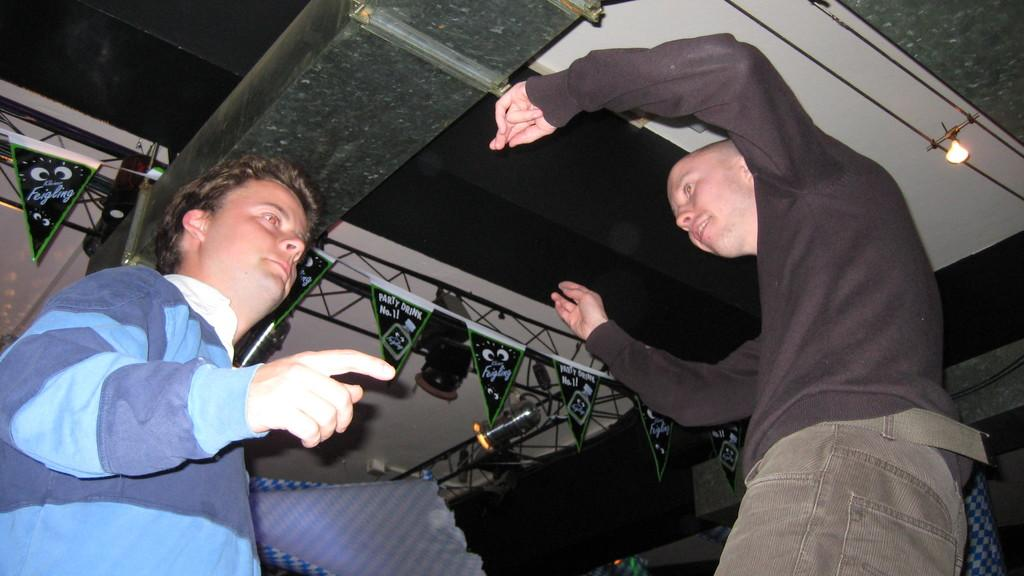How many people are present in the image? There are two men standing in the image. What can be seen hanging in the image? There are banners and a cloth hanging in the image. What structure is visible in the image? There is a roof visible in the image. What type of equipment is present in the image? There is a lighting truss in the image. What month is it in the image? The month cannot be determined from the image, as there is no information about the time of year. How many ladybugs are present in the image? There are no ladybugs present in the image. 